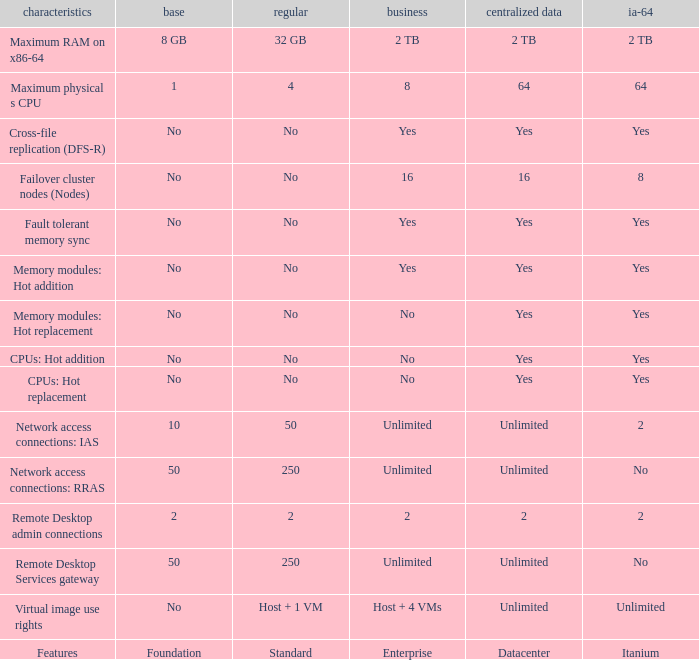What is the Datacenter for the Fault Tolerant Memory Sync Feature that has Yes for Itanium and No for Standard? Yes. 